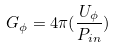<formula> <loc_0><loc_0><loc_500><loc_500>G _ { \phi } = 4 \pi ( \frac { U _ { \phi } } { P _ { i n } } )</formula> 